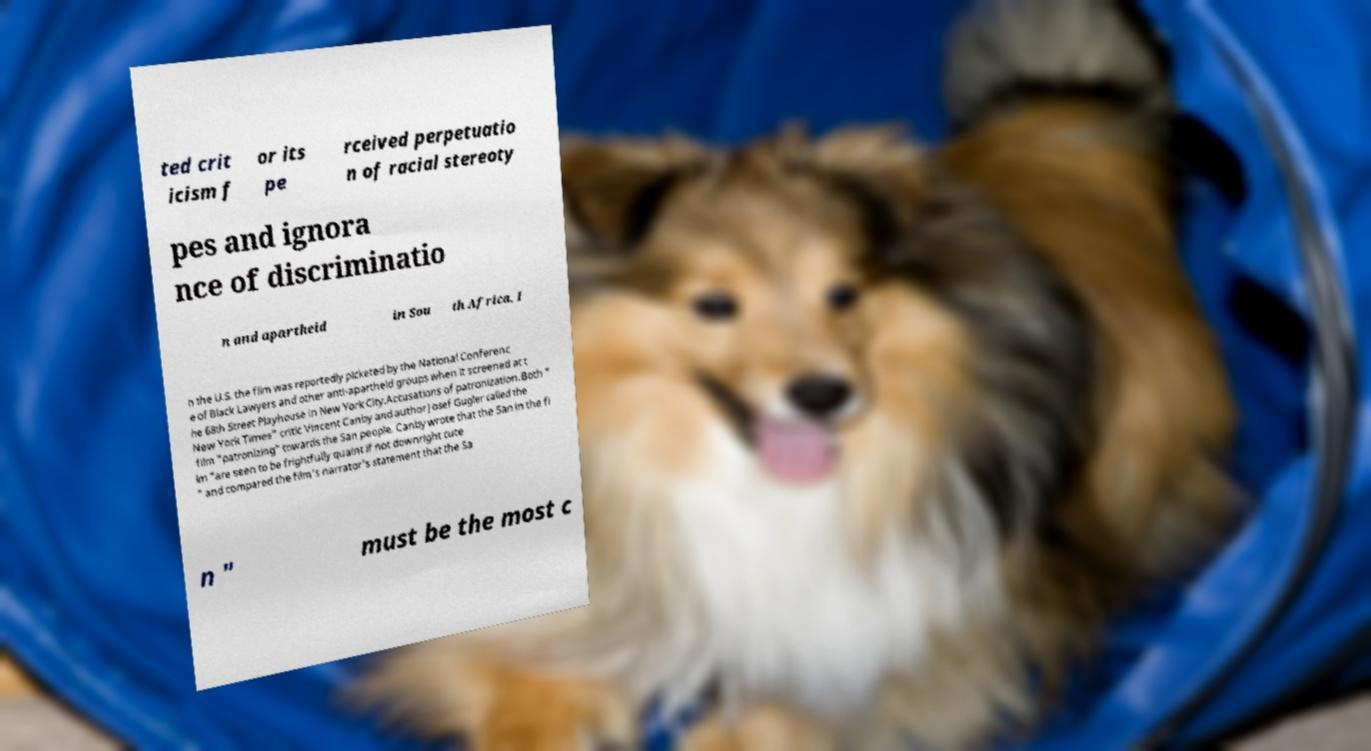There's text embedded in this image that I need extracted. Can you transcribe it verbatim? ted crit icism f or its pe rceived perpetuatio n of racial stereoty pes and ignora nce of discriminatio n and apartheid in Sou th Africa. I n the U.S. the film was reportedly picketed by the National Conferenc e of Black Lawyers and other anti-apartheid groups when it screened at t he 68th Street Playhouse in New York City.Accusations of patronization.Both " New York Times" critic Vincent Canby and author Josef Gugler called the film "patronizing" towards the San people. Canby wrote that the San in the fi lm "are seen to be frightfully quaint if not downright cute " and compared the film's narrator's statement that the Sa n " must be the most c 